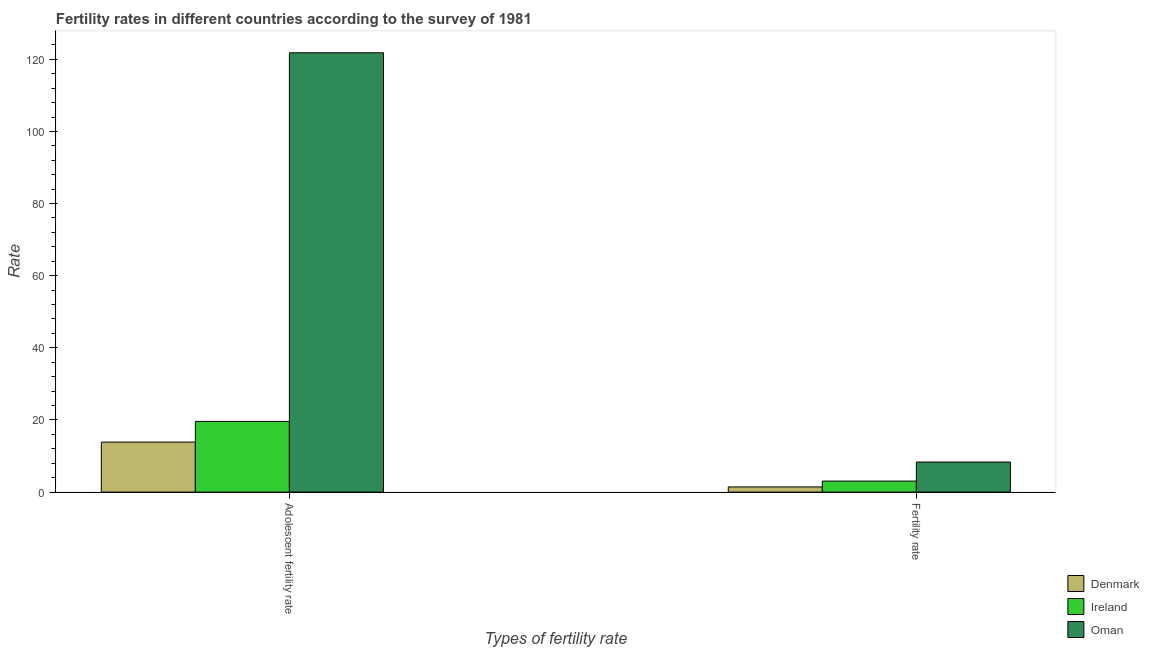How many different coloured bars are there?
Offer a very short reply. 3. How many groups of bars are there?
Offer a terse response. 2. Are the number of bars on each tick of the X-axis equal?
Keep it short and to the point. Yes. How many bars are there on the 1st tick from the left?
Offer a terse response. 3. What is the label of the 1st group of bars from the left?
Give a very brief answer. Adolescent fertility rate. What is the adolescent fertility rate in Oman?
Make the answer very short. 121.8. Across all countries, what is the maximum adolescent fertility rate?
Your response must be concise. 121.8. Across all countries, what is the minimum adolescent fertility rate?
Keep it short and to the point. 13.87. In which country was the adolescent fertility rate maximum?
Offer a terse response. Oman. In which country was the adolescent fertility rate minimum?
Provide a short and direct response. Denmark. What is the total adolescent fertility rate in the graph?
Your answer should be compact. 155.27. What is the difference between the adolescent fertility rate in Denmark and that in Ireland?
Give a very brief answer. -5.73. What is the difference between the adolescent fertility rate in Denmark and the fertility rate in Ireland?
Offer a very short reply. 10.82. What is the average fertility rate per country?
Your answer should be very brief. 4.28. What is the difference between the adolescent fertility rate and fertility rate in Oman?
Offer a terse response. 113.47. What is the ratio of the adolescent fertility rate in Ireland to that in Oman?
Provide a short and direct response. 0.16. Is the fertility rate in Denmark less than that in Oman?
Make the answer very short. Yes. In how many countries, is the adolescent fertility rate greater than the average adolescent fertility rate taken over all countries?
Make the answer very short. 1. What does the 2nd bar from the left in Fertility rate represents?
Provide a succinct answer. Ireland. What does the 3rd bar from the right in Adolescent fertility rate represents?
Your answer should be compact. Denmark. How many bars are there?
Make the answer very short. 6. How many countries are there in the graph?
Your response must be concise. 3. What is the difference between two consecutive major ticks on the Y-axis?
Your answer should be compact. 20. Does the graph contain grids?
Your response must be concise. No. Where does the legend appear in the graph?
Keep it short and to the point. Bottom right. What is the title of the graph?
Your response must be concise. Fertility rates in different countries according to the survey of 1981. Does "Belarus" appear as one of the legend labels in the graph?
Offer a very short reply. No. What is the label or title of the X-axis?
Give a very brief answer. Types of fertility rate. What is the label or title of the Y-axis?
Offer a terse response. Rate. What is the Rate in Denmark in Adolescent fertility rate?
Your answer should be very brief. 13.87. What is the Rate of Ireland in Adolescent fertility rate?
Provide a succinct answer. 19.6. What is the Rate of Oman in Adolescent fertility rate?
Make the answer very short. 121.8. What is the Rate in Denmark in Fertility rate?
Your response must be concise. 1.44. What is the Rate in Ireland in Fertility rate?
Give a very brief answer. 3.05. What is the Rate in Oman in Fertility rate?
Make the answer very short. 8.34. Across all Types of fertility rate, what is the maximum Rate in Denmark?
Provide a succinct answer. 13.87. Across all Types of fertility rate, what is the maximum Rate in Ireland?
Your response must be concise. 19.6. Across all Types of fertility rate, what is the maximum Rate of Oman?
Provide a short and direct response. 121.8. Across all Types of fertility rate, what is the minimum Rate of Denmark?
Offer a very short reply. 1.44. Across all Types of fertility rate, what is the minimum Rate in Ireland?
Your answer should be compact. 3.05. Across all Types of fertility rate, what is the minimum Rate in Oman?
Provide a succinct answer. 8.34. What is the total Rate in Denmark in the graph?
Ensure brevity in your answer.  15.31. What is the total Rate in Ireland in the graph?
Offer a terse response. 22.65. What is the total Rate in Oman in the graph?
Make the answer very short. 130.14. What is the difference between the Rate of Denmark in Adolescent fertility rate and that in Fertility rate?
Your answer should be compact. 12.43. What is the difference between the Rate of Ireland in Adolescent fertility rate and that in Fertility rate?
Your response must be concise. 16.55. What is the difference between the Rate of Oman in Adolescent fertility rate and that in Fertility rate?
Give a very brief answer. 113.47. What is the difference between the Rate of Denmark in Adolescent fertility rate and the Rate of Ireland in Fertility rate?
Your answer should be compact. 10.82. What is the difference between the Rate in Denmark in Adolescent fertility rate and the Rate in Oman in Fertility rate?
Offer a terse response. 5.53. What is the difference between the Rate of Ireland in Adolescent fertility rate and the Rate of Oman in Fertility rate?
Give a very brief answer. 11.26. What is the average Rate in Denmark per Types of fertility rate?
Your answer should be very brief. 7.65. What is the average Rate in Ireland per Types of fertility rate?
Offer a terse response. 11.32. What is the average Rate of Oman per Types of fertility rate?
Make the answer very short. 65.07. What is the difference between the Rate of Denmark and Rate of Ireland in Adolescent fertility rate?
Offer a very short reply. -5.73. What is the difference between the Rate in Denmark and Rate in Oman in Adolescent fertility rate?
Your answer should be very brief. -107.94. What is the difference between the Rate of Ireland and Rate of Oman in Adolescent fertility rate?
Your answer should be compact. -102.2. What is the difference between the Rate of Denmark and Rate of Ireland in Fertility rate?
Offer a very short reply. -1.61. What is the difference between the Rate in Denmark and Rate in Oman in Fertility rate?
Offer a terse response. -6.9. What is the difference between the Rate of Ireland and Rate of Oman in Fertility rate?
Your response must be concise. -5.29. What is the ratio of the Rate in Denmark in Adolescent fertility rate to that in Fertility rate?
Make the answer very short. 9.63. What is the ratio of the Rate of Ireland in Adolescent fertility rate to that in Fertility rate?
Your response must be concise. 6.43. What is the ratio of the Rate in Oman in Adolescent fertility rate to that in Fertility rate?
Your response must be concise. 14.61. What is the difference between the highest and the second highest Rate of Denmark?
Provide a short and direct response. 12.43. What is the difference between the highest and the second highest Rate in Ireland?
Your answer should be compact. 16.55. What is the difference between the highest and the second highest Rate in Oman?
Offer a terse response. 113.47. What is the difference between the highest and the lowest Rate in Denmark?
Your answer should be compact. 12.43. What is the difference between the highest and the lowest Rate of Ireland?
Ensure brevity in your answer.  16.55. What is the difference between the highest and the lowest Rate in Oman?
Provide a short and direct response. 113.47. 